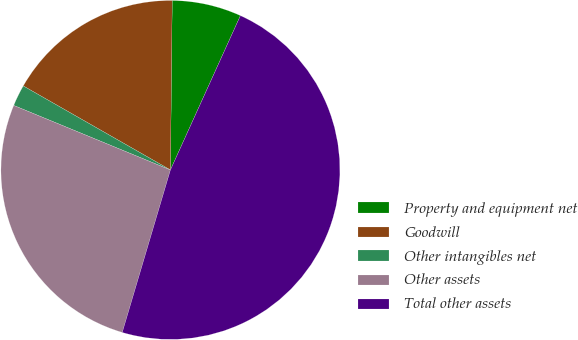<chart> <loc_0><loc_0><loc_500><loc_500><pie_chart><fcel>Property and equipment net<fcel>Goodwill<fcel>Other intangibles net<fcel>Other assets<fcel>Total other assets<nl><fcel>6.61%<fcel>16.91%<fcel>2.04%<fcel>26.63%<fcel>47.81%<nl></chart> 